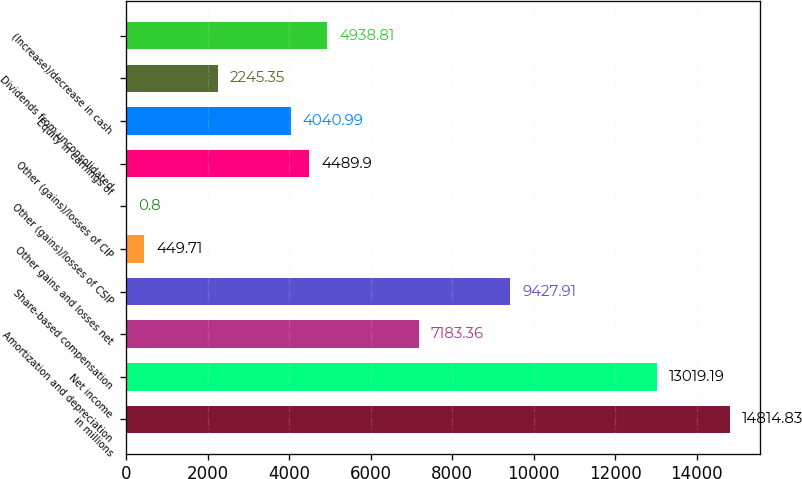Convert chart. <chart><loc_0><loc_0><loc_500><loc_500><bar_chart><fcel>in millions<fcel>Net income<fcel>Amortization and depreciation<fcel>Share-based compensation<fcel>Other gains and losses net<fcel>Other (gains)/losses of CSIP<fcel>Other (gains)/losses of CIP<fcel>Equity in earnings of<fcel>Dividends from unconsolidated<fcel>(Increase)/decrease in cash<nl><fcel>14814.8<fcel>13019.2<fcel>7183.36<fcel>9427.91<fcel>449.71<fcel>0.8<fcel>4489.9<fcel>4040.99<fcel>2245.35<fcel>4938.81<nl></chart> 